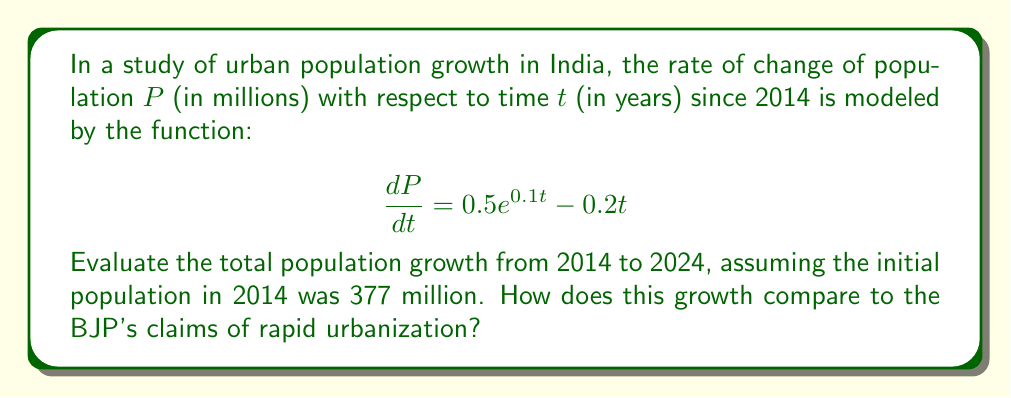Solve this math problem. To solve this problem, we need to integrate the given rate of change function and evaluate it over the specified time interval. Let's break it down step-by-step:

1) The population growth is given by the definite integral of the rate of change:

   $$\Delta P = \int_0^{10} (0.5e^{0.1t} - 0.2t) dt$$

2) Let's integrate each term separately:

   For $0.5e^{0.1t}$:
   $$\int 0.5e^{0.1t} dt = 0.5 \cdot \frac{1}{0.1} e^{0.1t} + C = 5e^{0.1t} + C$$

   For $-0.2t$:
   $$\int -0.2t dt = -0.1t^2 + C$$

3) Combining these, we get:

   $$\int (0.5e^{0.1t} - 0.2t) dt = 5e^{0.1t} - 0.1t^2 + C$$

4) Now, let's evaluate this from 0 to 10:

   $$\Delta P = [5e^{0.1t} - 0.1t^2]_0^{10}$$
   $$= (5e^1 - 0.1(10)^2) - (5e^0 - 0)$$
   $$= (5e - 10) - 5$$
   $$= 5e - 15$$
   $$\approx 0.59 \text{ million}$$

5) Therefore, the total population growth from 2014 to 2024 is approximately 0.59 million.

6) The final population in 2024 would be:
   $$377 + 0.59 = 377.59 \text{ million}$$

This growth rate is relatively modest compared to the rapid urbanization claims often made by the BJP. It suggests a more gradual urban population increase, which may be at odds with the party's narrative of accelerated urban development.
Answer: 0.59 million 